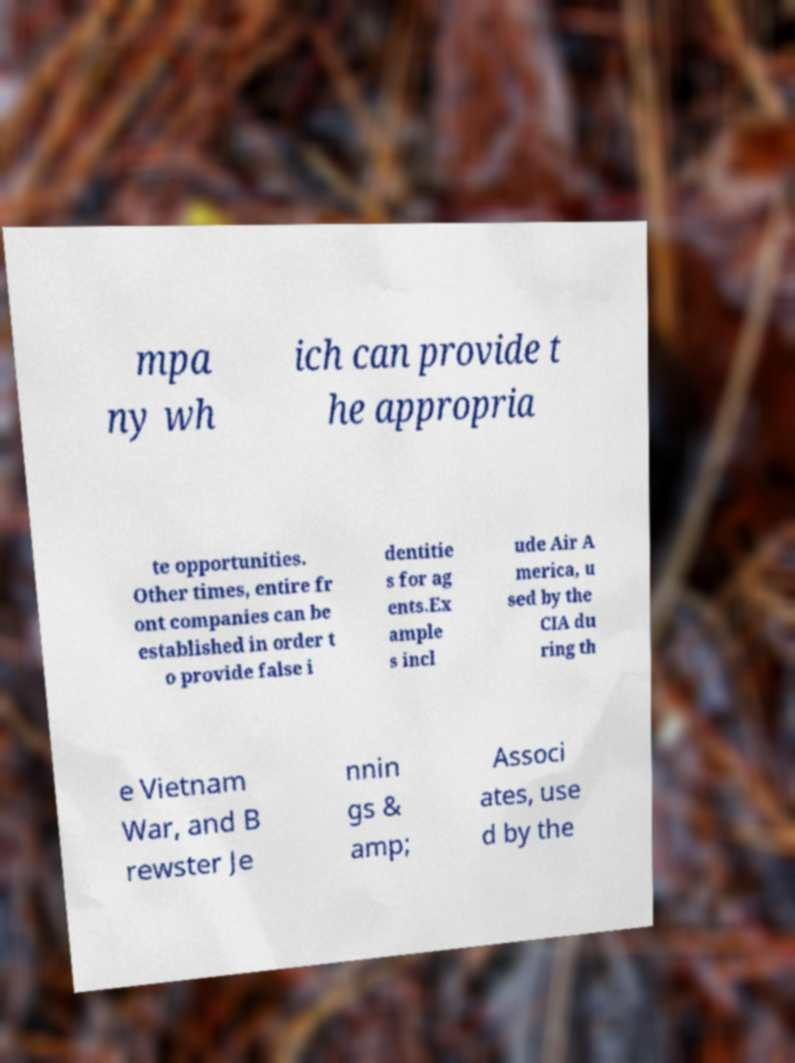I need the written content from this picture converted into text. Can you do that? mpa ny wh ich can provide t he appropria te opportunities. Other times, entire fr ont companies can be established in order t o provide false i dentitie s for ag ents.Ex ample s incl ude Air A merica, u sed by the CIA du ring th e Vietnam War, and B rewster Je nnin gs & amp; Associ ates, use d by the 